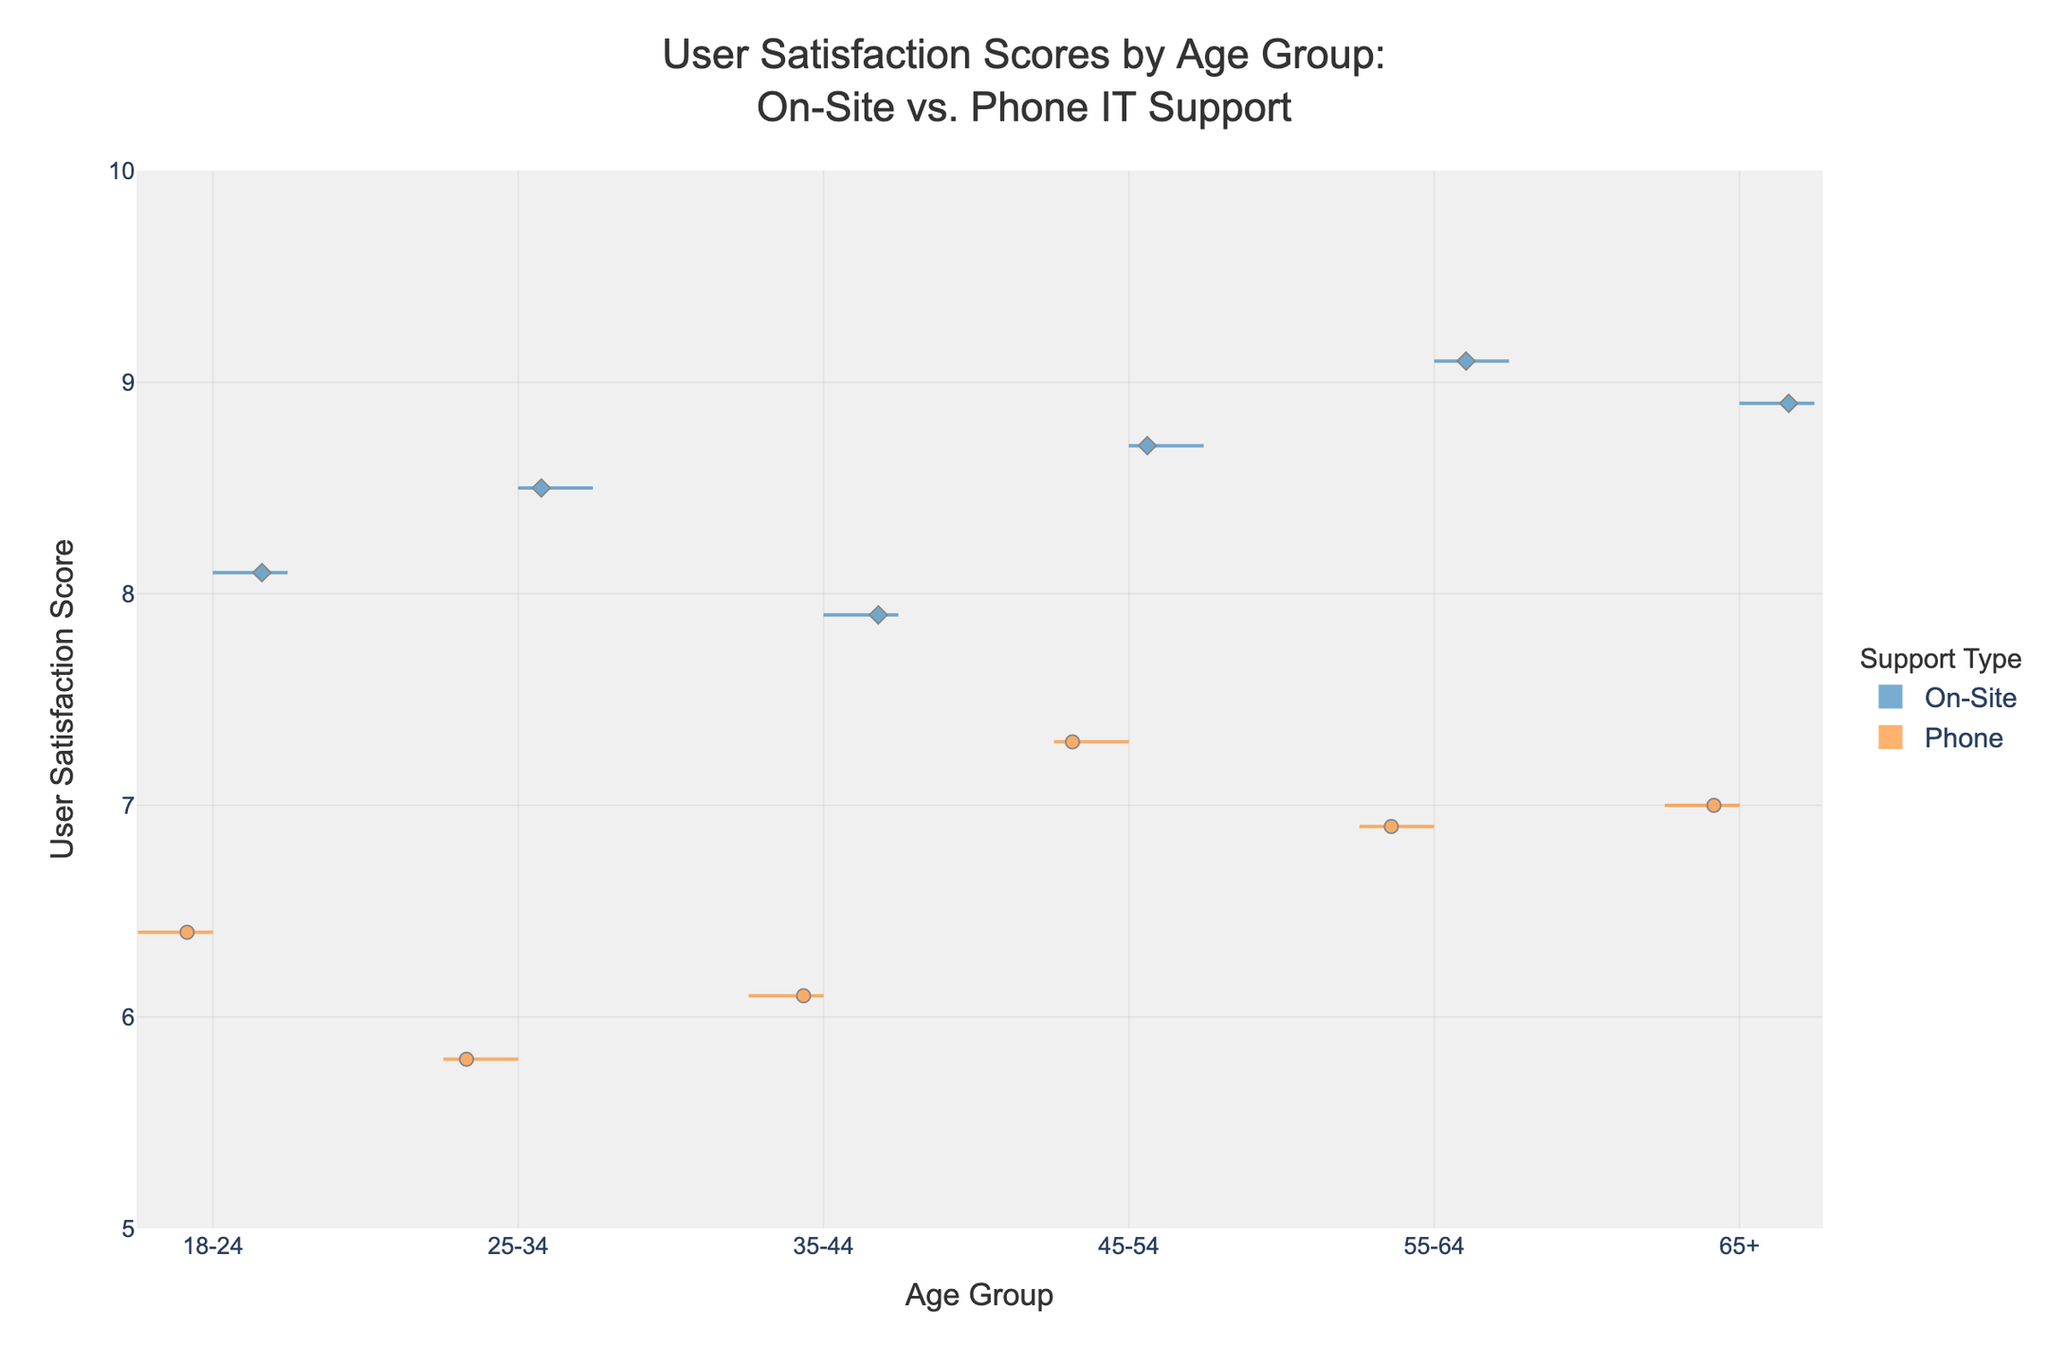What is the highest user satisfaction score for on-site support in the 35-44 age group? Look for the maximum score for on-site support in the 35-44 age group. The highest score is 9.2.
Answer: 9.2 What is the overall trend of user satisfaction scores between on-site and phone support for all age groups? Compare each age group's satisfaction scores for on-site and phone support. On-site support consistently has higher satisfaction scores across all age groups compared to phone support.
Answer: On-site support scores are higher What age group has the lowest user satisfaction score for phone support? Examine the lowest phone support scores for each age group. The 65+ age group has the lowest score of 5.9.
Answer: 65+ How do the user satisfaction scores for on-site support in the 18-24 age group compare to those in the 45-54 age group? Compare the distributions and central tendencies of the scores for on-site support between the 18-24 and 45-54 age groups. The scores for both age groups are similar, with slight variations mostly around the scores above 8.0.
Answer: Similar Which age group shows the smallest difference in user satisfaction scores between on-site and phone support? Compare differences in scores for on-site and phone support across age groups. The 35-44 age group has the smallest difference between on-site and phone support scores.
Answer: 35-44 What's the average satisfaction score for phone support in the 45-54 age group? Sum the scores for phone support in the 45-54 age group and divide by the number of data points: (6.7 + 7.0 + 6.8) / 3 = 6.83.
Answer: 6.83 In which age group is the median satisfaction score highest for on-site support? Determine the median of on-site support scores for each age group and compare them. The median is highest in the 35-44 age group, where the median is 9.0.
Answer: 35-44 Which support type and age group combination shows the most variability in user satisfaction scores? Look for the largest spread in the data distribution for all age groups and support types. Phone support in the 18-24 age group shows the most spread, indicating the highest variability.
Answer: Phone support (18-24) 